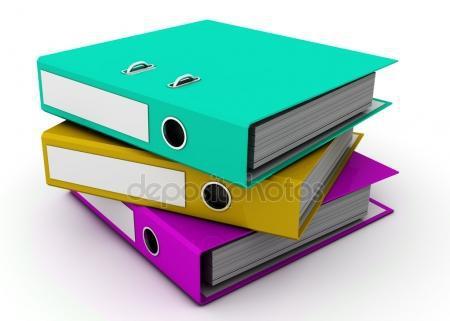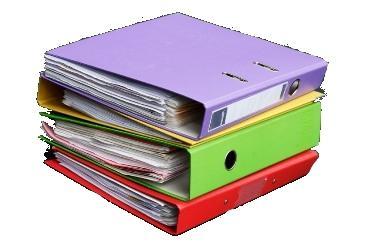The first image is the image on the left, the second image is the image on the right. Assess this claim about the two images: "There is a stack of three binders in the image on the right.". Correct or not? Answer yes or no. Yes. The first image is the image on the left, the second image is the image on the right. For the images displayed, is the sentence "One image shows multiple different colored binders without any labels on their ends, and the other image shows different colored binders with end labels." factually correct? Answer yes or no. No. 